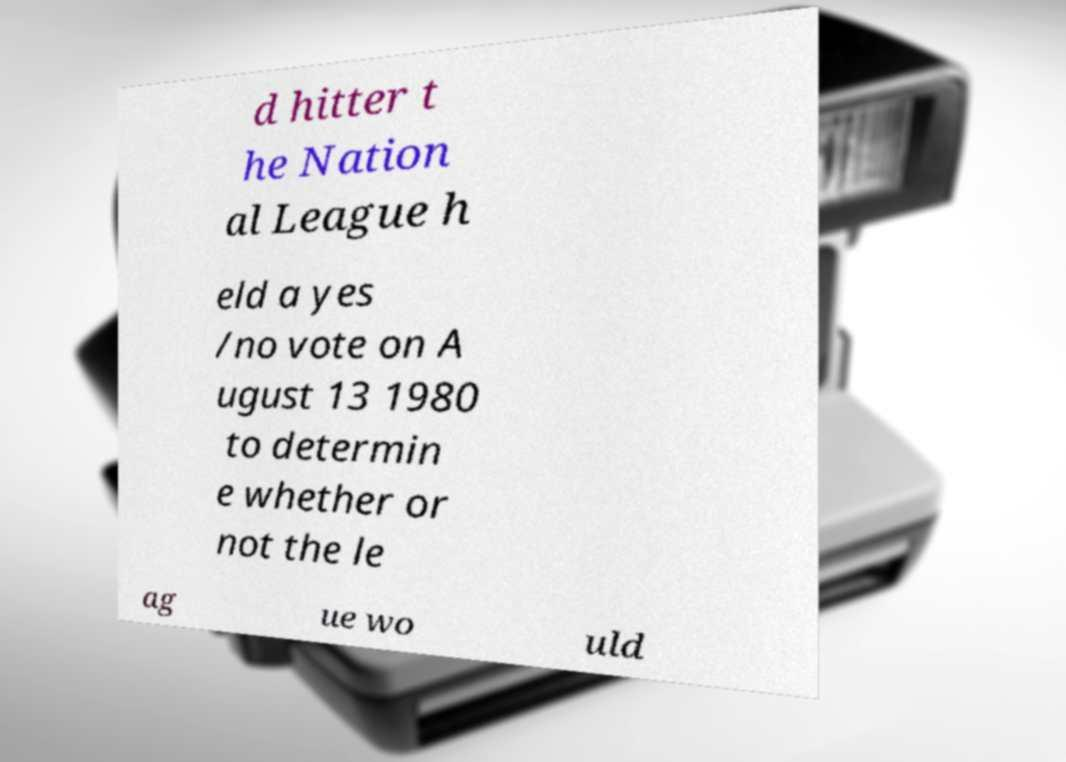Could you assist in decoding the text presented in this image and type it out clearly? d hitter t he Nation al League h eld a yes /no vote on A ugust 13 1980 to determin e whether or not the le ag ue wo uld 